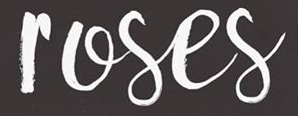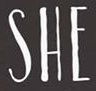Identify the words shown in these images in order, separated by a semicolon. roses; SHE 